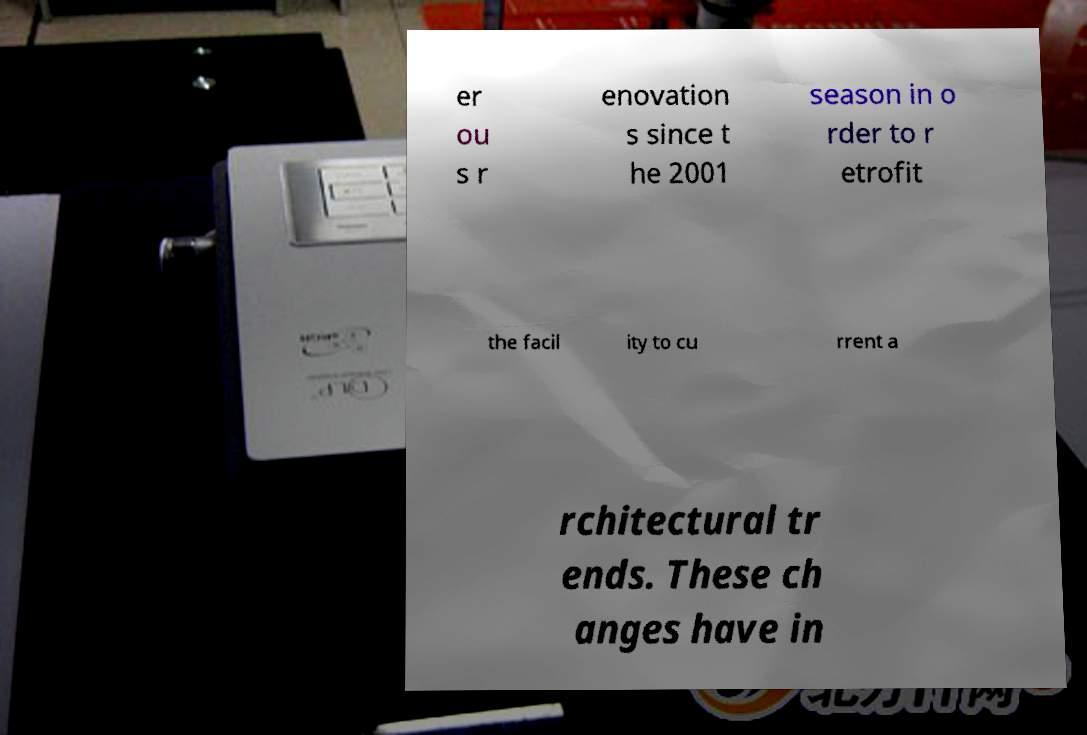Could you assist in decoding the text presented in this image and type it out clearly? er ou s r enovation s since t he 2001 season in o rder to r etrofit the facil ity to cu rrent a rchitectural tr ends. These ch anges have in 